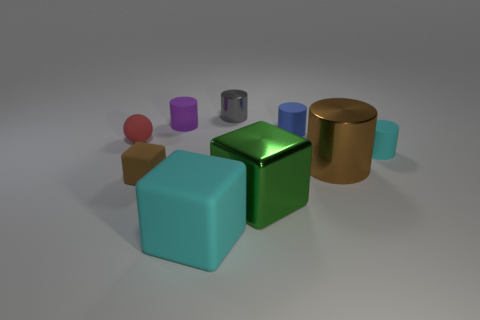What is the shape of the purple object?
Your answer should be compact. Cylinder. The cyan matte thing left of the small cylinder that is on the right side of the large metal cylinder is what shape?
Ensure brevity in your answer.  Cube. There is a big cylinder that is the same color as the tiny rubber cube; what is its material?
Make the answer very short. Metal. There is a sphere that is the same material as the small purple cylinder; what is its color?
Provide a succinct answer. Red. There is a matte cylinder in front of the tiny red object; is its color the same as the big object that is on the left side of the tiny gray cylinder?
Your response must be concise. Yes. Are there more tiny matte balls behind the brown metallic cylinder than balls to the right of the green thing?
Your response must be concise. Yes. There is another shiny object that is the same shape as the big brown shiny thing; what is its color?
Provide a short and direct response. Gray. Is there any other thing that has the same shape as the tiny red thing?
Your answer should be very brief. No. Do the big brown thing and the cyan matte thing that is to the left of the green thing have the same shape?
Keep it short and to the point. No. How many other things are there of the same material as the big brown thing?
Make the answer very short. 2. 